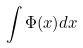Convert formula to latex. <formula><loc_0><loc_0><loc_500><loc_500>\int \Phi ( x ) d x</formula> 